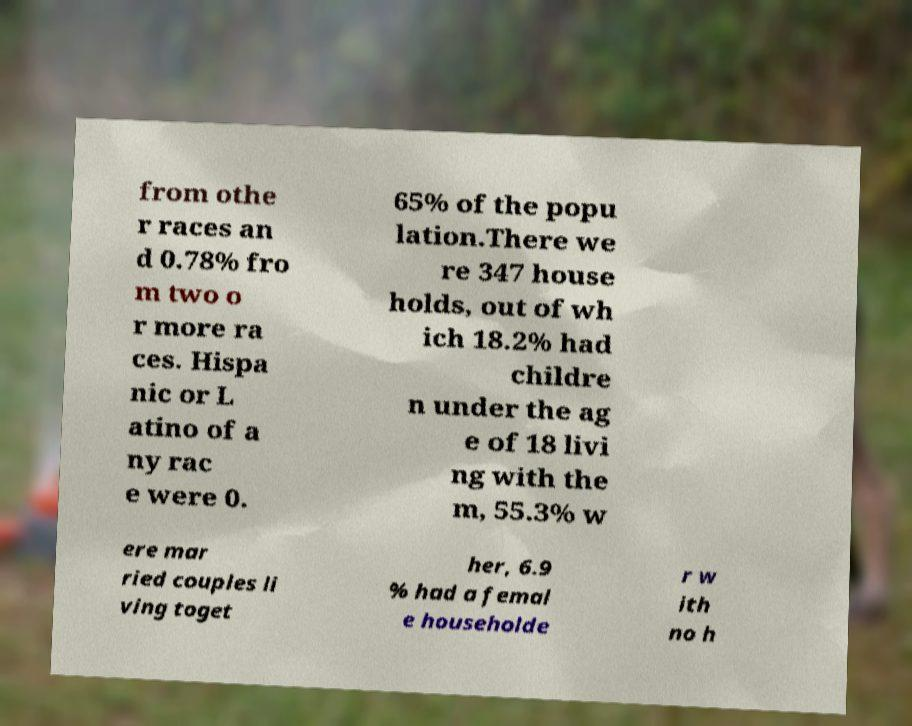Can you accurately transcribe the text from the provided image for me? from othe r races an d 0.78% fro m two o r more ra ces. Hispa nic or L atino of a ny rac e were 0. 65% of the popu lation.There we re 347 house holds, out of wh ich 18.2% had childre n under the ag e of 18 livi ng with the m, 55.3% w ere mar ried couples li ving toget her, 6.9 % had a femal e householde r w ith no h 